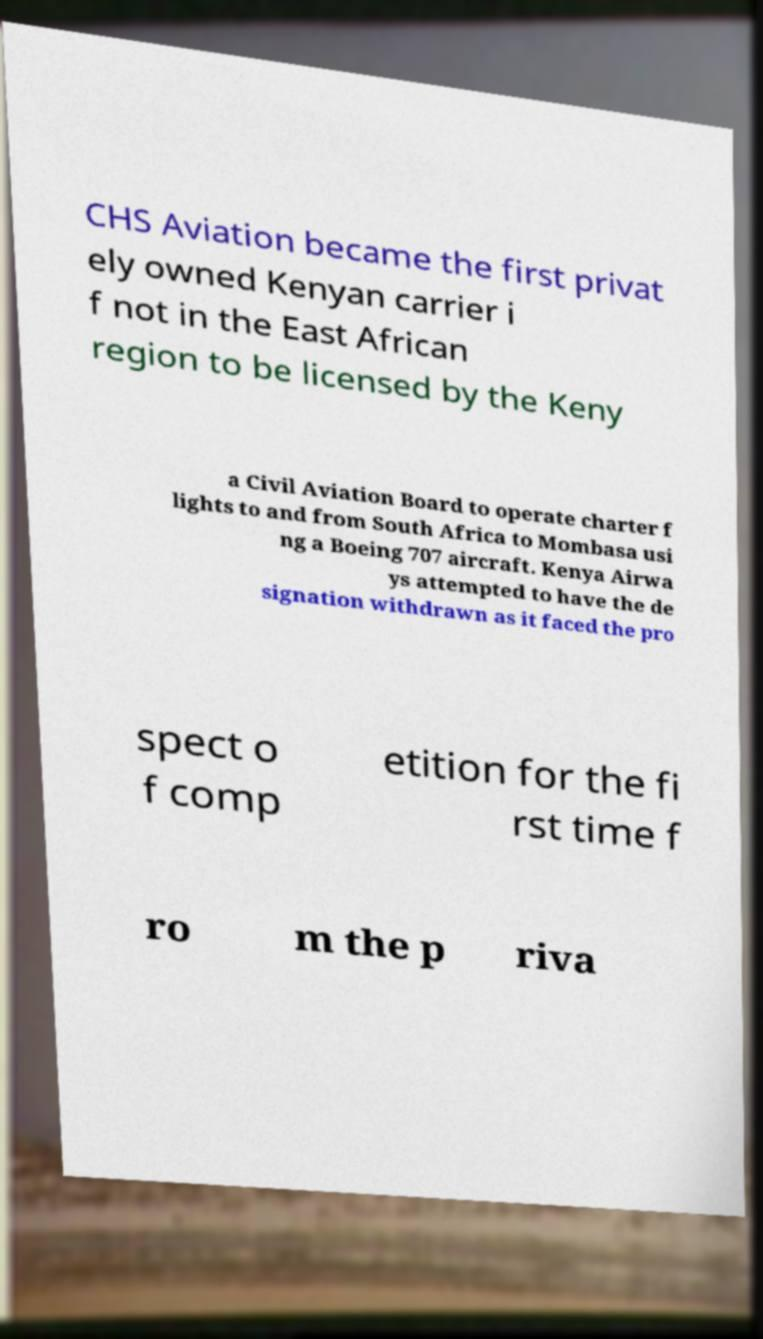Please identify and transcribe the text found in this image. CHS Aviation became the first privat ely owned Kenyan carrier i f not in the East African region to be licensed by the Keny a Civil Aviation Board to operate charter f lights to and from South Africa to Mombasa usi ng a Boeing 707 aircraft. Kenya Airwa ys attempted to have the de signation withdrawn as it faced the pro spect o f comp etition for the fi rst time f ro m the p riva 